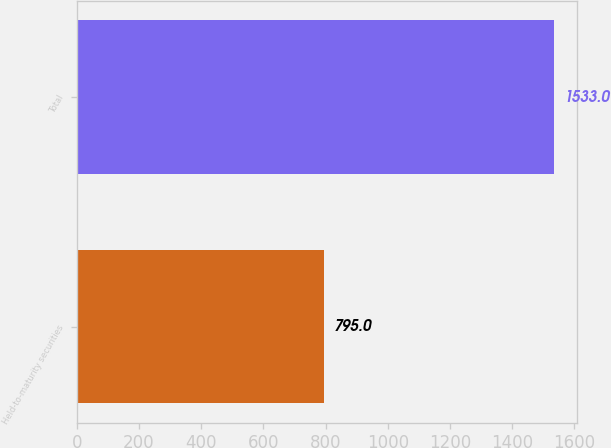Convert chart. <chart><loc_0><loc_0><loc_500><loc_500><bar_chart><fcel>Held-to-maturity securities<fcel>Total<nl><fcel>795<fcel>1533<nl></chart> 